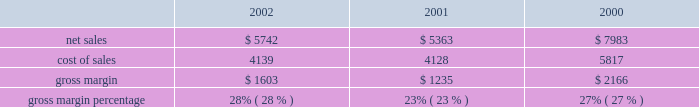In a new business model such as the retail segment is inherently risky , particularly in light of the significant investment involved , the current economic climate , and the fixed nature of a substantial portion of the retail segment's operating expenses .
Results for this segment are dependent upon a number of risks and uncertainties , some of which are discussed below under the heading "factors that may affect future results and financial condition." backlog in the company's experience , the actual amount of product backlog at any particular time is not a meaningful indication of its future business prospects .
In particular , backlog often increases in anticipation of or immediately following new product introductions because of over- ordering by dealers anticipating shortages .
Backlog often is reduced once dealers and customers believe they can obtain sufficient supply .
Because of the foregoing , backlog cannot be considered a reliable indicator of the company's ability to achieve any particular level of revenue or financial performance .
Further information regarding the company's backlog may be found below under the heading "factors that may affect future results and financial condition." gross margin gross margin for the three fiscal years ended september 28 , 2002 are as follows ( in millions , except gross margin percentages ) : gross margin increased to 28% ( 28 % ) of net sales in 2002 from 23% ( 23 % ) in 2001 .
As discussed below , gross margin in 2001 was unusually low resulting from negative gross margin of 2% ( 2 % ) experienced in the first quarter of 2001 .
As a percentage of net sales , the company's quarterly gross margins declined during fiscal 2002 from 31% ( 31 % ) in the first quarter down to 26% ( 26 % ) in the fourth quarter .
This decline resulted from several factors including a rise in component costs as the year progressed and aggressive pricing by the company across its products lines instituted as a result of continued pricing pressures in the personal computer industry .
The company anticipates that its gross margin and the gross margin of the overall personal computer industry will remain under pressure throughout fiscal 2003 in light of weak economic conditions , flat demand for personal computers in general , and the resulting pressure on prices .
The foregoing statements regarding anticipated gross margin in 2003 and the general demand for personal computers during 2003 are forward- looking .
Gross margin could differ from anticipated levels because of several factors , including certain of those set forth below in the subsection entitled "factors that may affect future results and financial condition." there can be no assurance that current gross margins will be maintained , targeted gross margin levels will be achieved , or current margins on existing individual products will be maintained .
In general , gross margins and margins on individual products will remain under significant downward pressure due to a variety of factors , including continued industry wide global pricing pressures , increased competition , compressed product life cycles , potential increases in the cost and availability of raw material and outside manufacturing services , and potential changes to the company's product mix , including higher unit sales of consumer products with lower average selling prices and lower gross margins .
In response to these downward pressures , the company expects it will continue to take pricing actions with respect to its products .
Gross margins could also be affected by the company's ability to effectively manage quality problems and warranty costs and to stimulate demand for certain of its products .
The company's operating strategy and pricing take into account anticipated changes in foreign currency exchange rates over time ; however , the company's results of operations can be significantly affected in the short-term by fluctuations in exchange rates .
The company orders components for its products and builds inventory in advance of product shipments .
Because the company's markets are volatile and subject to rapid technology and price changes , there is a risk the company will forecast incorrectly and produce or order from third parties excess or insufficient inventories of particular products or components .
The company's operating results and financial condition have been in the past and may in the future be materially adversely affected by the company's ability to manage its inventory levels and outstanding purchase commitments and to respond to short-term shifts in customer demand patterns .
Gross margin declined to 23% ( 23 % ) of net sales in 2001 from 27% ( 27 % ) in 2000 .
This decline resulted primarily from gross margin of negative 2% ( 2 % ) experienced during the first quarter of 2001 compared to 26% ( 26 % ) gross margin for the same quarter in 2000 .
In addition to lower than normal net .

What was the percentage change in net sales from 2000 to 2001? 
Computations: ((5363 - 7983) / 7983)
Answer: -0.3282. 